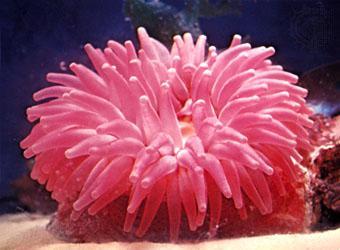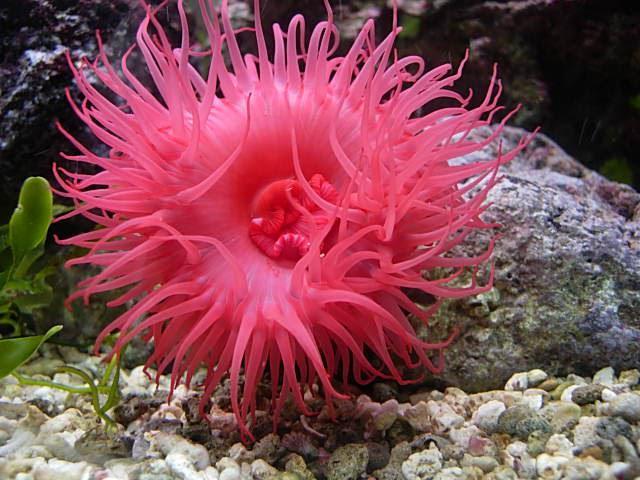The first image is the image on the left, the second image is the image on the right. Analyze the images presented: Is the assertion "Both images show anemones with similar vibrant warm coloring." valid? Answer yes or no. Yes. 